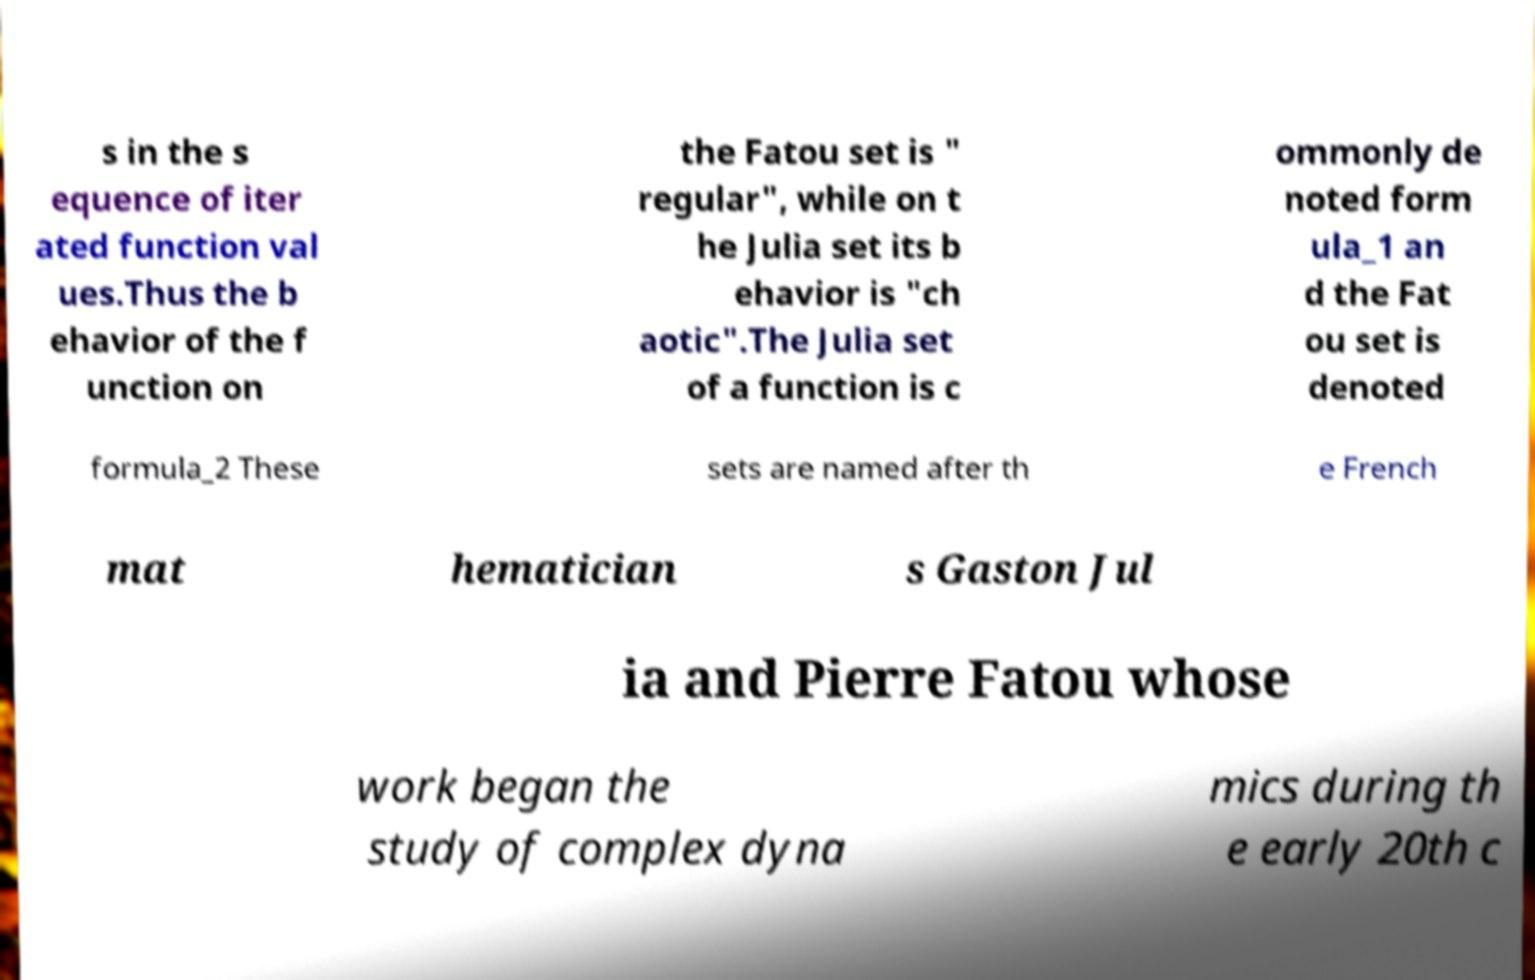Please read and relay the text visible in this image. What does it say? s in the s equence of iter ated function val ues.Thus the b ehavior of the f unction on the Fatou set is " regular", while on t he Julia set its b ehavior is "ch aotic".The Julia set of a function is c ommonly de noted form ula_1 an d the Fat ou set is denoted formula_2 These sets are named after th e French mat hematician s Gaston Jul ia and Pierre Fatou whose work began the study of complex dyna mics during th e early 20th c 